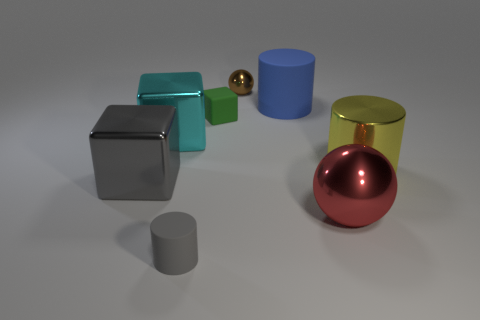Add 1 large cyan matte things. How many objects exist? 9 Subtract all cylinders. How many objects are left? 5 Subtract 1 red balls. How many objects are left? 7 Subtract all yellow rubber spheres. Subtract all yellow metal cylinders. How many objects are left? 7 Add 8 small cubes. How many small cubes are left? 9 Add 4 tiny purple matte things. How many tiny purple matte things exist? 4 